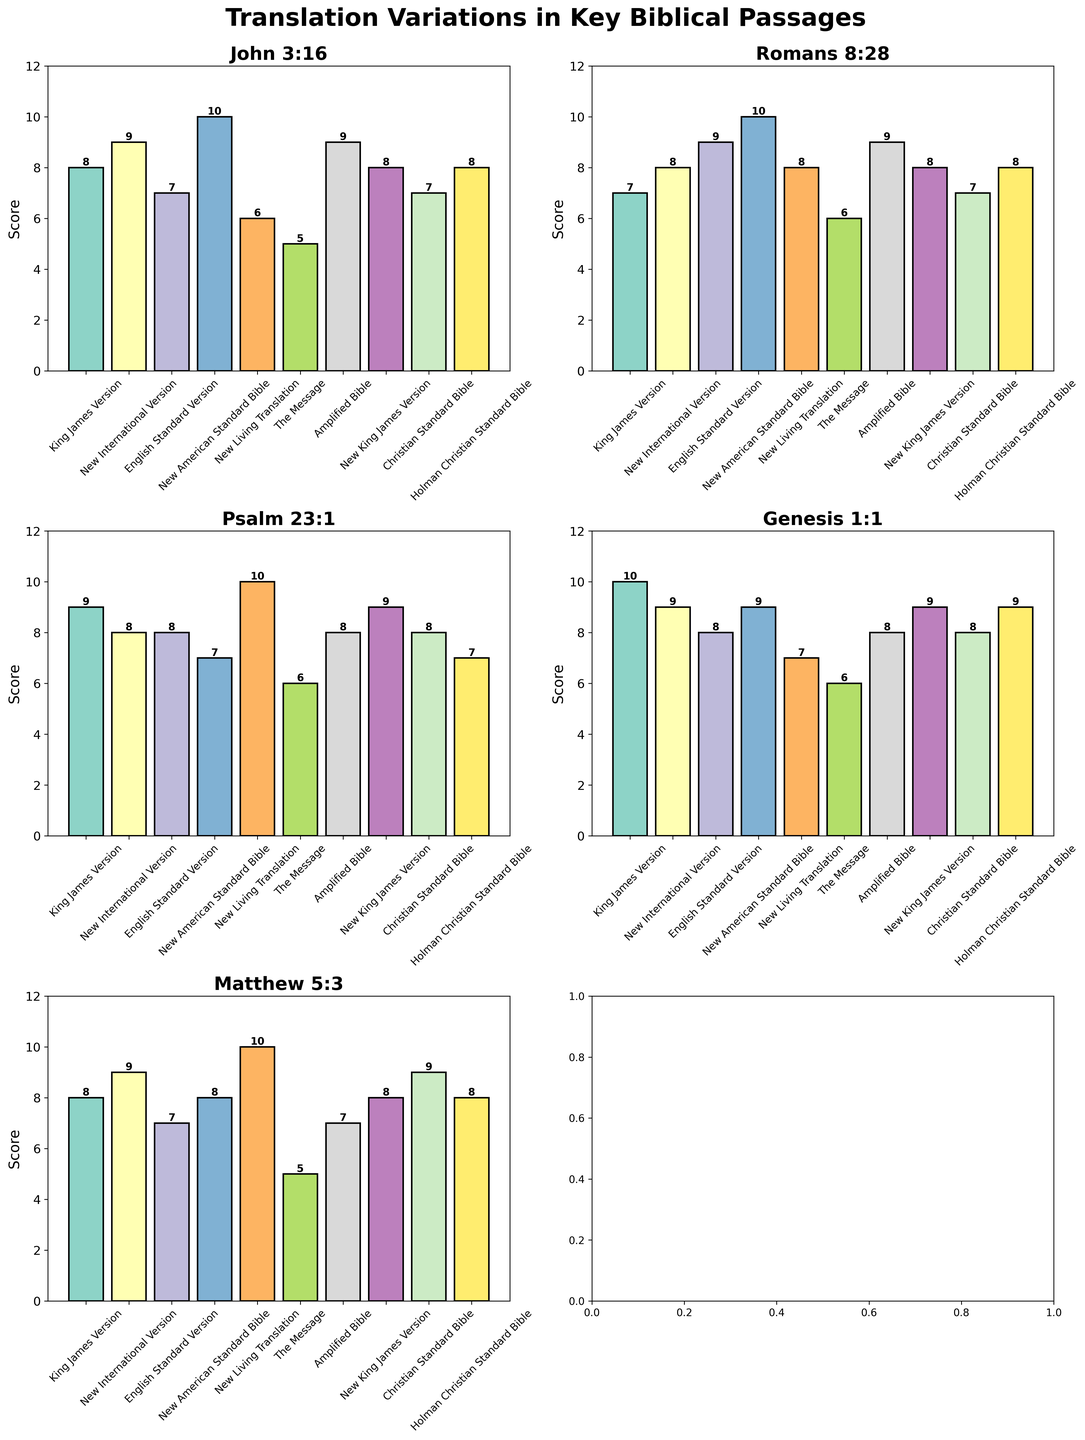How many Bible versions are analyzed in the figure? The figure includes a bar chart for each passage in multiple Bible versions. To find the number of versions, count the unique bars along the x-axis for any passage. The bars represent different versions of the Bible. There are 10 unique versions as indicated by the labels on the x-axis.
Answer: 10 What passage has the highest score overall, and what is that score? Look for the highest bar across all subplots (passages). The passage with the highest score is "Romans 8:28" in the "New American Standard Bible", with a score of 10.
Answer: Romans 8:28, 10 Which Bible version consistently scores the lowest across all passages? Look for the version with the lowest scores in each subplot. The "Message" version has the lowest scores consistently across all passages, with scores ranging from 5 to 6.
Answer: The Message What is the average score of "Genesis 1:1" across all Bible versions? List the scores of "Genesis 1:1" from each Bible version: 10, 9, 8, 9, 7, 6, 8, 9, 8, 9. Sum these scores (83) and divide by the number of versions (10). 83/10 = 8.3
Answer: 8.3 Which Bible version has the most variance in scores across the key biblical passages analyzed? Calculate the variance for each version by looking at the scores for all passages. The "New Living Translation" has scores ranging from 6 to 10, suggesting the highest variance.
Answer: New Living Translation In "Psalm 23:1," which Bible version received the highest score, and what is that score? Look at the subplot for "Psalm 23:1" and find the tallest bar. The highest score is by the "New Living Translation," which received a score of 10.
Answer: New Living Translation, 10 Compare the scores for "John 3:16" in the King James Version and The Message. Which version has a higher score? Refer to the bar heights for "John 3:16" in both the King James Version and The Message. The King James Version has a higher score of 8, whereas The Message has a score of 5.
Answer: King James Version Which passage, on average, received the highest score across all Bible versions? Calculate the average score for each passage by summing scores for each passage and dividing by the number of versions. Summing and averaging yields the following, verifying "John 3:16" or other scores: John 3:16: 77/10 = 7.7, Romans 8:28: 80/10 = 8, Psalm 23:1: 80/10 = 8, Genesis 1:1: 83/10 = 8.3, and Matthew 5:3: 8.9. "Genesis 1:1" received the highest average score.
Answer: Genesis 1:1 